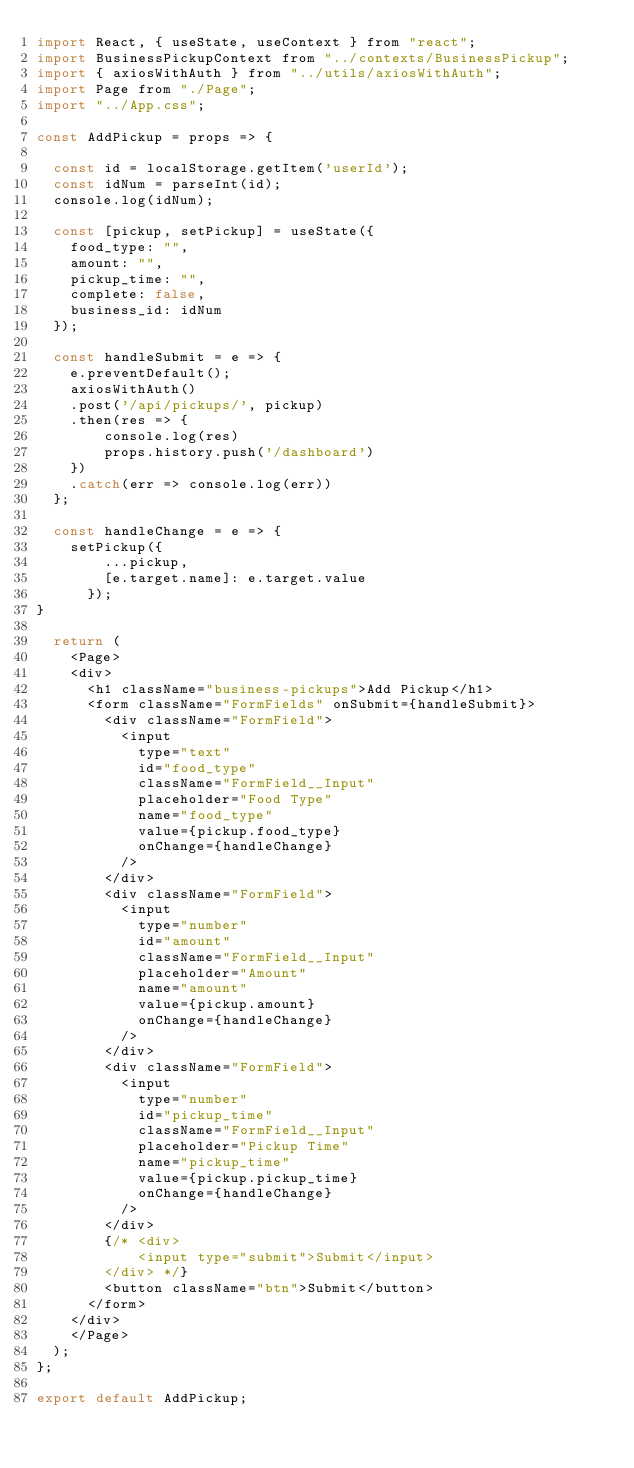Convert code to text. <code><loc_0><loc_0><loc_500><loc_500><_JavaScript_>import React, { useState, useContext } from "react";
import BusinessPickupContext from "../contexts/BusinessPickup";
import { axiosWithAuth } from "../utils/axiosWithAuth";
import Page from "./Page";
import "../App.css";

const AddPickup = props => {

  const id = localStorage.getItem('userId');
  const idNum = parseInt(id);
  console.log(idNum);

  const [pickup, setPickup] = useState({
    food_type: "",
    amount: "",
    pickup_time: "",
    complete: false,
    business_id: idNum
  });

  const handleSubmit = e => {
    e.preventDefault();
    axiosWithAuth()
    .post('/api/pickups/', pickup)
    .then(res => {
        console.log(res)
        props.history.push('/dashboard')
    })
    .catch(err => console.log(err))
  };

  const handleChange = e => {
    setPickup({
        ...pickup,
        [e.target.name]: e.target.value
      });
}

  return (
    <Page>
    <div>
      <h1 className="business-pickups">Add Pickup</h1>
      <form className="FormFields" onSubmit={handleSubmit}>
        <div className="FormField">
          <input
            type="text"
            id="food_type"
            className="FormField__Input"
            placeholder="Food Type"
            name="food_type"
            value={pickup.food_type}
            onChange={handleChange}
          />
        </div>
        <div className="FormField">
          <input
            type="number"
            id="amount"
            className="FormField__Input"
            placeholder="Amount"
            name="amount"
            value={pickup.amount}
            onChange={handleChange}
          />
        </div>
        <div className="FormField">
          <input
            type="number"
            id="pickup_time"
            className="FormField__Input"
            placeholder="Pickup Time"
            name="pickup_time"
            value={pickup.pickup_time}
            onChange={handleChange}
          />
        </div>
        {/* <div>
            <input type="submit">Submit</input>
        </div> */}
        <button className="btn">Submit</button>
      </form>
    </div>
    </Page>
  );
};

export default AddPickup;
</code> 